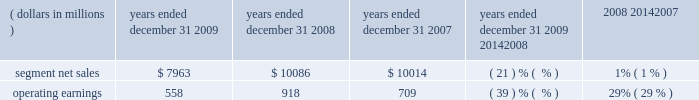Management 2019s discussion and analysis of financial condition and results of operations in 2008 , asp was flat compared to 2007 .
By comparison , asp decreased approximately 9% ( 9 % ) in 2007 and decreased approximately 11% ( 11 % ) in 2006 .
The segment has several large customers located throughout the world .
In 2008 , aggregate net sales to the segment 2019s five largest customers accounted for approximately 41% ( 41 % ) of the segment 2019s net sales .
Besides selling directly to carriers and operators , the segment also sells products through a variety of third-party distributors and retailers , which accounted for approximately 24% ( 24 % ) of the segment 2019s net sales in 2008 .
Although the u.s .
Market continued to be the segment 2019s largest individual market , many of our customers , and 56% ( 56 % ) of the segment 2019s 2008 net sales , were outside the u.s .
In 2008 , the largest of these international markets were brazil , china and mexico .
As the segment 2019s revenue transactions are largely denominated in local currencies , we are impacted by the weakening in the value of these local currencies against the u.s .
Dollar .
A number of our more significant international markets , particularly in latin america , were impacted by this trend in late 2008 .
Home and networks mobility segment the home and networks mobility segment designs , manufactures , sells , installs and services : ( i ) digital video , internet protocol video and broadcast network interactive set-tops , end-to-end video distribution systems , broadband access infrastructure platforms , and associated data and voice customer premise equipment to cable television and telecom service providers ( collectively , referred to as the 2018 2018home business 2019 2019 ) , and ( ii ) wireless access systems , including cellular infrastructure systems and wireless broadband systems , to wireless service providers ( collectively , referred to as the 2018 2018network business 2019 2019 ) .
In 2009 , the segment 2019s net sales represented 36% ( 36 % ) of the company 2019s consolidated net sales , compared to 33% ( 33 % ) in 2008 and 27% ( 27 % ) in 2007 .
Years ended december 31 percent change ( dollars in millions ) 2009 2008 2007 2009 20142008 2008 20142007 .
Segment results 20142009 compared to 2008 in 2009 , the segment 2019s net sales were $ 8.0 billion , a decrease of 21% ( 21 % ) compared to net sales of $ 10.1 billion in 2008 .
The 21% ( 21 % ) decrease in net sales reflects a 22% ( 22 % ) decrease in net sales in the networks business and a 21% ( 21 % ) decrease in net sales in the home business .
The 22% ( 22 % ) decrease in net sales in the networks business was primarily driven by lower net sales of gsm , cdma , umts and iden infrastructure equipment , partially offset by higher net sales of wimax products .
The 21% ( 21 % ) decrease in net sales in the home business was primarily driven by a 24% ( 24 % ) decrease in net sales of digital entertainment devices , reflecting : ( i ) an 18% ( 18 % ) decrease in shipments of digital entertainment devices , primarily due to lower shipments to large cable and telecommunications operators in north america as a result of macroeconomic conditions , and ( ii ) a lower asp due to an unfavorable shift in product mix .
The segment shipped 14.7 million digital entertainment devices in 2009 , compared to 18.0 million shipped in 2008 .
On a geographic basis , the 21% ( 21 % ) decrease in net sales was driven by lower net sales in all regions .
The decrease in net sales in north america was primarily due to : ( i ) lower net sales in the home business , and ( ii ) lower net sales of cdma and iden infrastructure equipment , partially offset by higher net sales of wimax products .
The decrease in net sales in emea was primarily due to lower net sales of gsm infrastructure equipment , partially offset by higher net sales of wimax products and higher net sales in the home business .
The decrease in net sales in asia was primarily driven by lower net sales of gsm , umts and cdma infrastructure equipment , partially offset by higher net sales in the home business .
The decrease in net sales in latin america was primarily due to : ( i ) lower net sales in the home business , and ( ii ) lower net sales of iden infrastructure equipment , partially offset by higher net sales of wimax products .
Net sales in north america accounted for approximately 51% ( 51 % ) of the segment 2019s total net sales in 2009 , compared to approximately 50% ( 50 % ) of the segment 2019s total net sales in 2008. .
What was the aggerate net sales in 2008? 
Rationale: in line 4 , it states that the aggerate net sales for 2008 was 41% of the segment net sales . therefore to calculate aggerate net sales , you much multiple segment net sales by 41% .
Computations: (10086 * 41%)
Answer: 4135.26. 